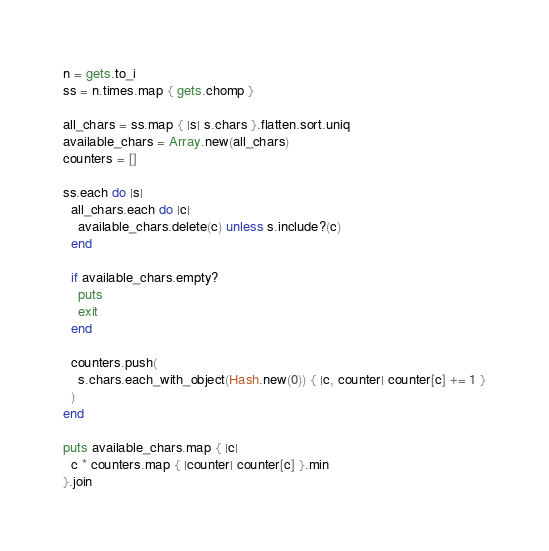Convert code to text. <code><loc_0><loc_0><loc_500><loc_500><_Ruby_>n = gets.to_i
ss = n.times.map { gets.chomp }

all_chars = ss.map { |s| s.chars }.flatten.sort.uniq
available_chars = Array.new(all_chars)
counters = []

ss.each do |s|
  all_chars.each do |c|
    available_chars.delete(c) unless s.include?(c)
  end

  if available_chars.empty?
    puts
    exit
  end

  counters.push(
    s.chars.each_with_object(Hash.new(0)) { |c, counter| counter[c] += 1 }
  )
end

puts available_chars.map { |c|
  c * counters.map { |counter| counter[c] }.min
}.join
</code> 